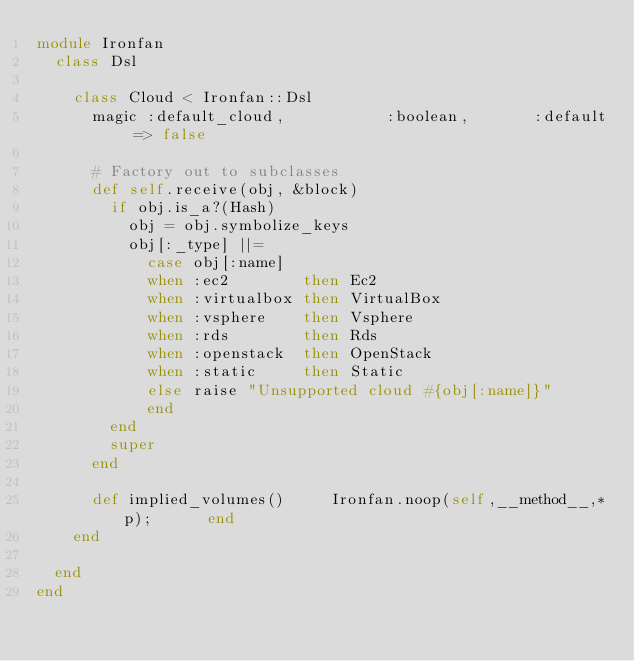Convert code to text. <code><loc_0><loc_0><loc_500><loc_500><_Ruby_>module Ironfan
  class Dsl

    class Cloud < Ironfan::Dsl
      magic :default_cloud,           :boolean,       :default => false

      # Factory out to subclasses
      def self.receive(obj, &block)
        if obj.is_a?(Hash)
          obj = obj.symbolize_keys
          obj[:_type] ||=
            case obj[:name]
            when :ec2        then Ec2
            when :virtualbox then VirtualBox
            when :vsphere    then Vsphere
            when :rds        then Rds
            when :openstack  then OpenStack
            when :static     then Static
            else raise "Unsupported cloud #{obj[:name]}"
            end
        end
        super
      end

      def implied_volumes()     Ironfan.noop(self,__method__,*p);      end
    end

  end
end
</code> 